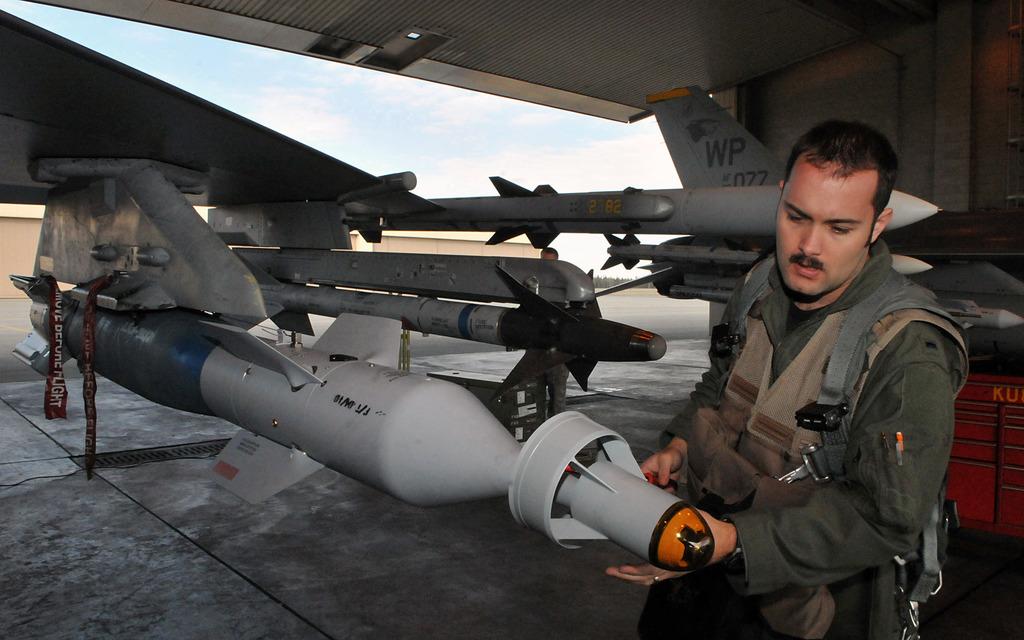The red tape should be removed before what?
Make the answer very short. Flight. 